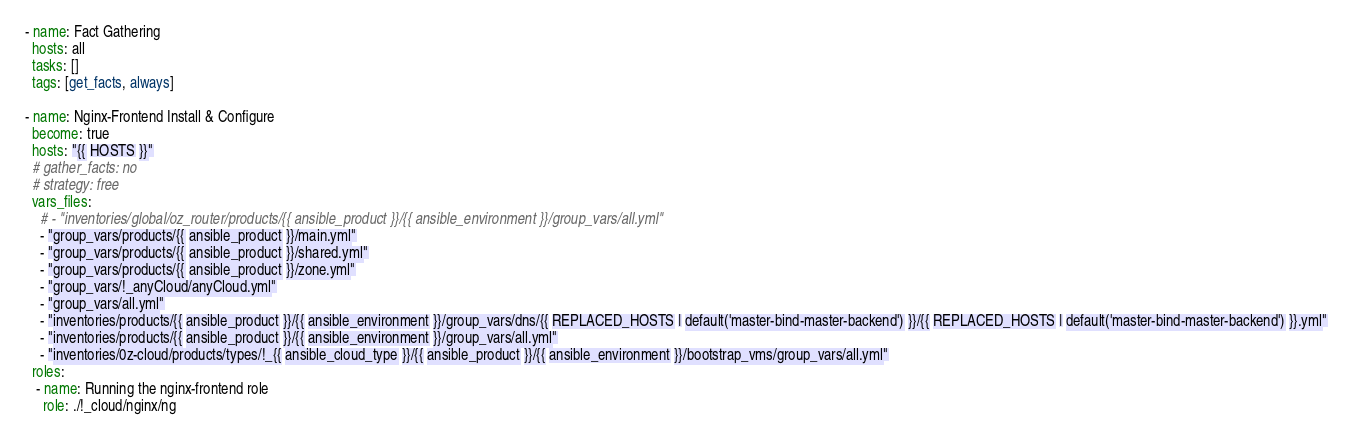Convert code to text. <code><loc_0><loc_0><loc_500><loc_500><_YAML_>- name: Fact Gathering
  hosts: all
  tasks: []
  tags: [get_facts, always]

- name: Nginx-Frontend Install & Configure
  become: true
  hosts: "{{ HOSTS }}"
  # gather_facts: no
  # strategy: free
  vars_files:
    # - "inventories/global/oz_router/products/{{ ansible_product }}/{{ ansible_environment }}/group_vars/all.yml"
    - "group_vars/products/{{ ansible_product }}/main.yml"
    - "group_vars/products/{{ ansible_product }}/shared.yml"
    - "group_vars/products/{{ ansible_product }}/zone.yml"
    - "group_vars/!_anyCloud/anyCloud.yml"
    - "group_vars/all.yml"
    - "inventories/products/{{ ansible_product }}/{{ ansible_environment }}/group_vars/dns/{{ REPLACED_HOSTS | default('master-bind-master-backend') }}/{{ REPLACED_HOSTS | default('master-bind-master-backend') }}.yml"
    - "inventories/products/{{ ansible_product }}/{{ ansible_environment }}/group_vars/all.yml"
    - "inventories/0z-cloud/products/types/!_{{ ansible_cloud_type }}/{{ ansible_product }}/{{ ansible_environment }}/bootstrap_vms/group_vars/all.yml"
  roles:
   - name: Running the nginx-frontend role
     role: ./!_cloud/nginx/ng
</code> 